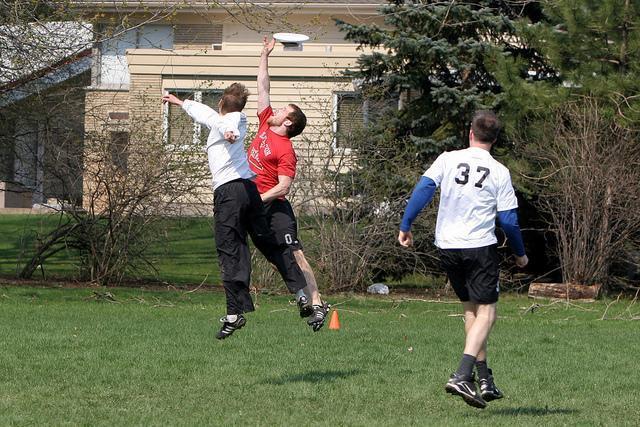How many people can be seen?
Give a very brief answer. 3. How many airplanes are there?
Give a very brief answer. 0. 